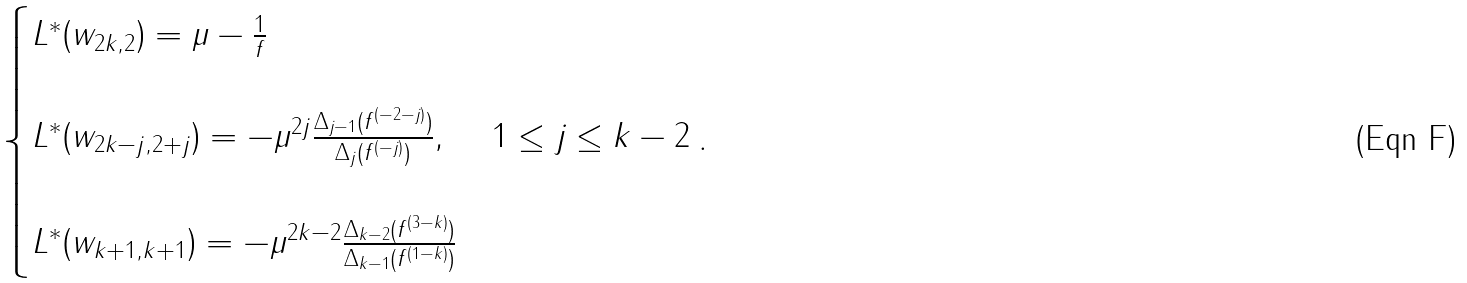<formula> <loc_0><loc_0><loc_500><loc_500>\begin{cases} L ^ { * } ( w _ { 2 k , 2 } ) = \mu - \frac { 1 } { f } & \\ \\ L ^ { * } ( w _ { 2 k - j , 2 + j } ) = - \mu ^ { 2 j } \frac { \Delta _ { j - 1 } ( f ^ { ( - 2 - j ) } ) } { \Delta _ { j } ( f ^ { ( - j ) } ) } , & 1 \leq j \leq k - 2 \\ \\ L ^ { * } ( w _ { k + 1 , k + 1 } ) = - \mu ^ { 2 k - 2 } \frac { \Delta _ { k - 2 } ( f ^ { ( 3 - k ) } ) } { \Delta _ { k - 1 } ( f ^ { ( 1 - k ) } ) } \end{cases} .</formula> 